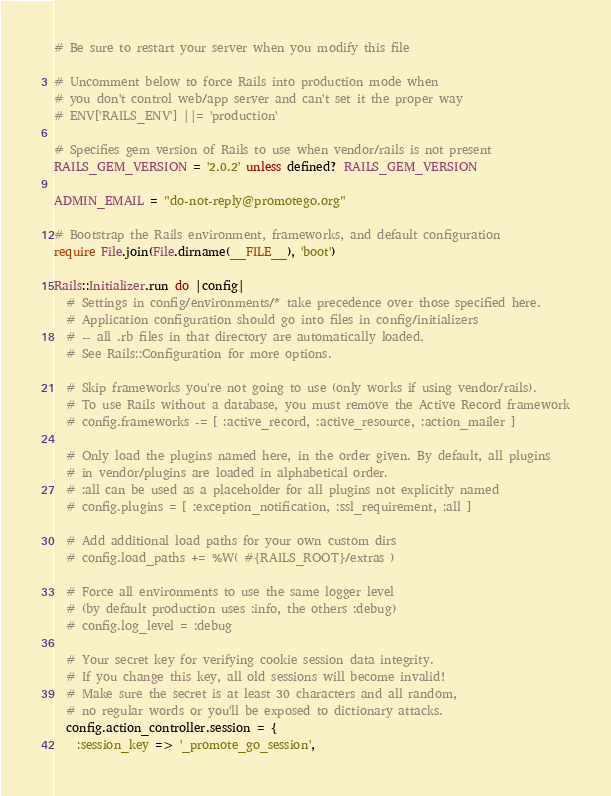<code> <loc_0><loc_0><loc_500><loc_500><_Ruby_># Be sure to restart your server when you modify this file

# Uncomment below to force Rails into production mode when
# you don't control web/app server and can't set it the proper way
# ENV['RAILS_ENV'] ||= 'production'

# Specifies gem version of Rails to use when vendor/rails is not present
RAILS_GEM_VERSION = '2.0.2' unless defined? RAILS_GEM_VERSION

ADMIN_EMAIL = "do-not-reply@promotego.org"

# Bootstrap the Rails environment, frameworks, and default configuration
require File.join(File.dirname(__FILE__), 'boot')

Rails::Initializer.run do |config|
  # Settings in config/environments/* take precedence over those specified here.
  # Application configuration should go into files in config/initializers
  # -- all .rb files in that directory are automatically loaded.
  # See Rails::Configuration for more options.

  # Skip frameworks you're not going to use (only works if using vendor/rails).
  # To use Rails without a database, you must remove the Active Record framework
  # config.frameworks -= [ :active_record, :active_resource, :action_mailer ]

  # Only load the plugins named here, in the order given. By default, all plugins 
  # in vendor/plugins are loaded in alphabetical order.
  # :all can be used as a placeholder for all plugins not explicitly named
  # config.plugins = [ :exception_notification, :ssl_requirement, :all ]

  # Add additional load paths for your own custom dirs
  # config.load_paths += %W( #{RAILS_ROOT}/extras )

  # Force all environments to use the same logger level
  # (by default production uses :info, the others :debug)
  # config.log_level = :debug

  # Your secret key for verifying cookie session data integrity.
  # If you change this key, all old sessions will become invalid!
  # Make sure the secret is at least 30 characters and all random, 
  # no regular words or you'll be exposed to dictionary attacks.
  config.action_controller.session = {
    :session_key => '_promote_go_session',</code> 